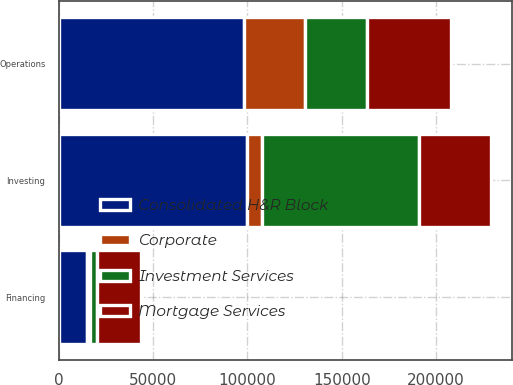Convert chart to OTSL. <chart><loc_0><loc_0><loc_500><loc_500><stacked_bar_chart><ecel><fcel>Operations<fcel>Investing<fcel>Financing<nl><fcel>Investment Services<fcel>32408<fcel>83534<fcel>3482<nl><fcel>Consolidated H&R Block<fcel>98303<fcel>99906<fcel>15126<nl><fcel>Mortgage Services<fcel>44657<fcel>37816<fcel>23223<nl><fcel>Corporate<fcel>32408<fcel>7618<fcel>1686<nl></chart> 